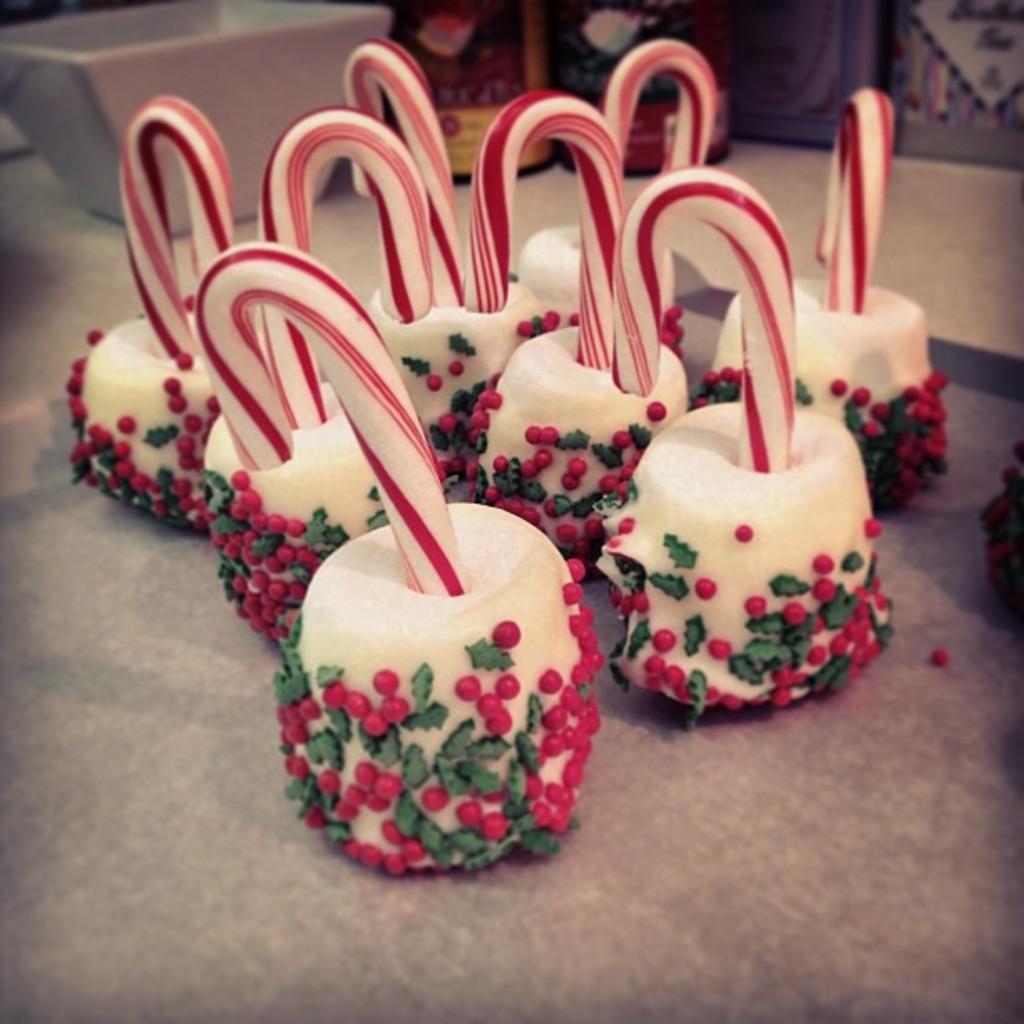How would you summarize this image in a sentence or two? In this picture we can see there are candles on an object. At the top of the image, there is a bowl and some objects. 